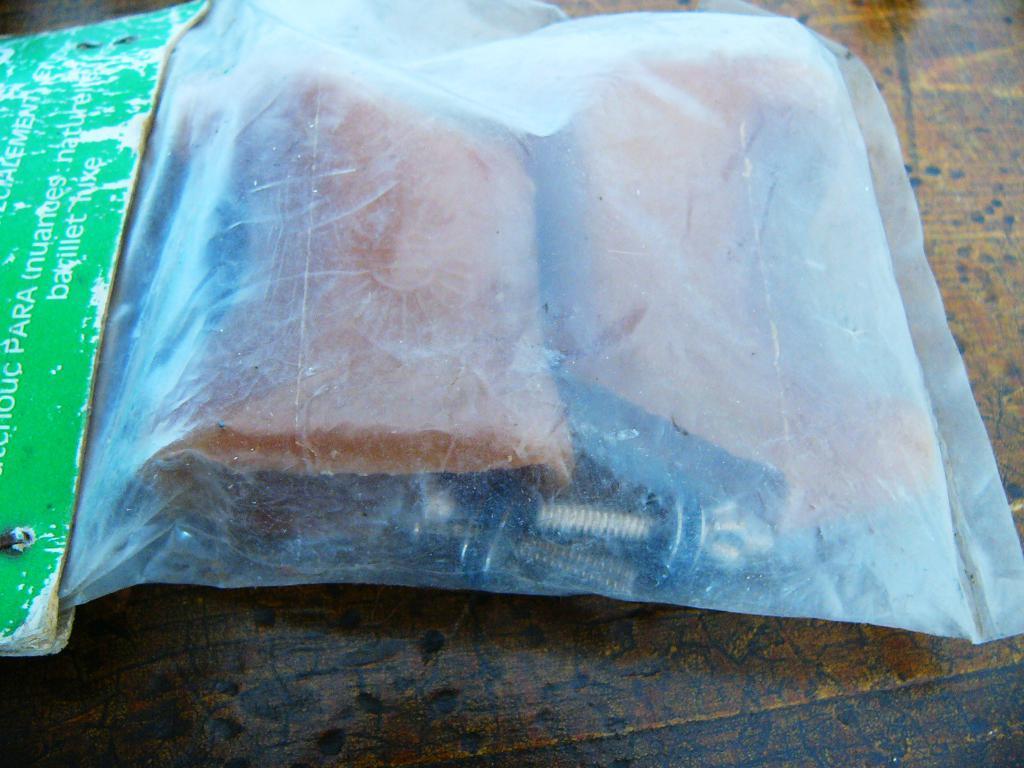Please provide a concise description of this image. In this image we can see some things which are packed in plastic cover is on the wooden surface. 